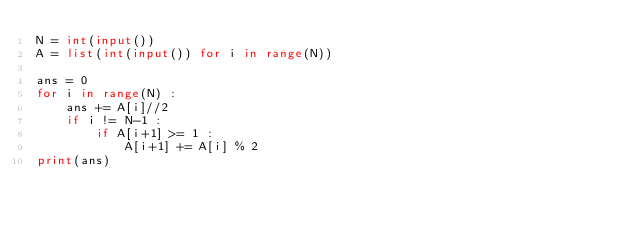Convert code to text. <code><loc_0><loc_0><loc_500><loc_500><_Python_>N = int(input())
A = list(int(input()) for i in range(N))

ans = 0
for i in range(N) :
    ans += A[i]//2
    if i != N-1 :
        if A[i+1] >= 1 :
            A[i+1] += A[i] % 2
print(ans)
</code> 